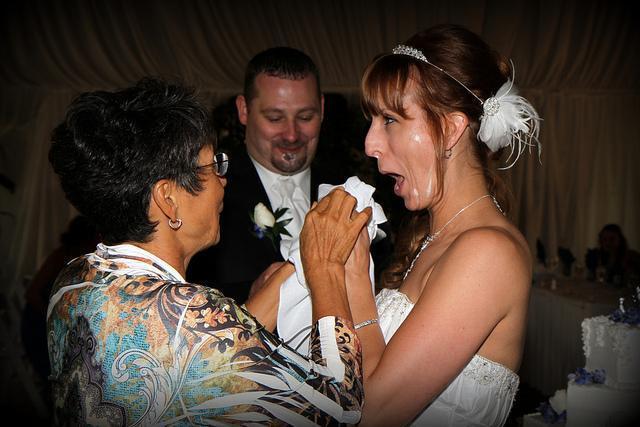How many people can you see?
Give a very brief answer. 3. 